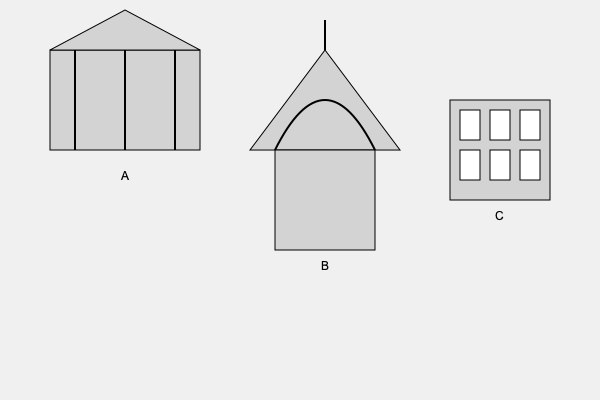Identify the correct chronological order of the architectural styles represented by the buildings labeled A, B, and C in the image. To answer this question, we need to analyze the architectural features of each building and match them to their respective historical periods:

1. Building A: This structure shows characteristics of Ancient Greek architecture:
   - Rectangular base with columns (temple structure)
   - Triangular pediment (roof)
   - Simple, symmetrical design
   This represents the Classical period of Ancient Greece (5th-4th century BCE).

2. Building B: This structure displays features of Gothic architecture:
   - Pointed arch
   - Tall, vertical emphasis
   - Spire at the top
   Gothic architecture flourished during the High and Late Middle Ages (12th-16th centuries CE).

3. Building C: This building exhibits elements of Renaissance architecture:
   - Symmetrical facade
   - Regular arrangement of windows
   - Emphasis on horizontal lines and proportions
   The Renaissance period in architecture spans from the 15th to the 17th century CE.

Therefore, the correct chronological order is:
A (Ancient Greek) → B (Gothic) → C (Renaissance)
Answer: A, B, C 